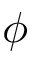<formula> <loc_0><loc_0><loc_500><loc_500>\phi</formula> 